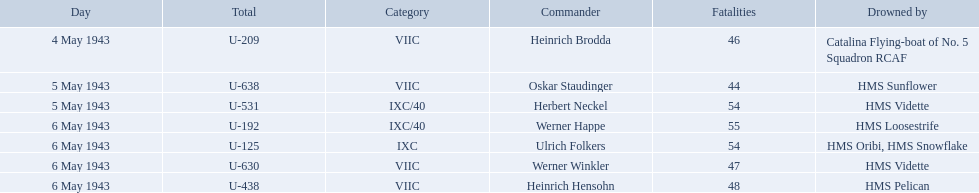Who are the captains of the u boats? Heinrich Brodda, Oskar Staudinger, Herbert Neckel, Werner Happe, Ulrich Folkers, Werner Winkler, Heinrich Hensohn. What are the dates the u boat captains were lost? 4 May 1943, 5 May 1943, 5 May 1943, 6 May 1943, 6 May 1943, 6 May 1943, 6 May 1943. Of these, which were lost on may 5? Oskar Staudinger, Herbert Neckel. Other than oskar staudinger, who else was lost on this day? Herbert Neckel. What is the list of ships under sunk by? Catalina Flying-boat of No. 5 Squadron RCAF, HMS Sunflower, HMS Vidette, HMS Loosestrife, HMS Oribi, HMS Snowflake, HMS Vidette, HMS Pelican. Which captains did hms pelican sink? Heinrich Hensohn. 